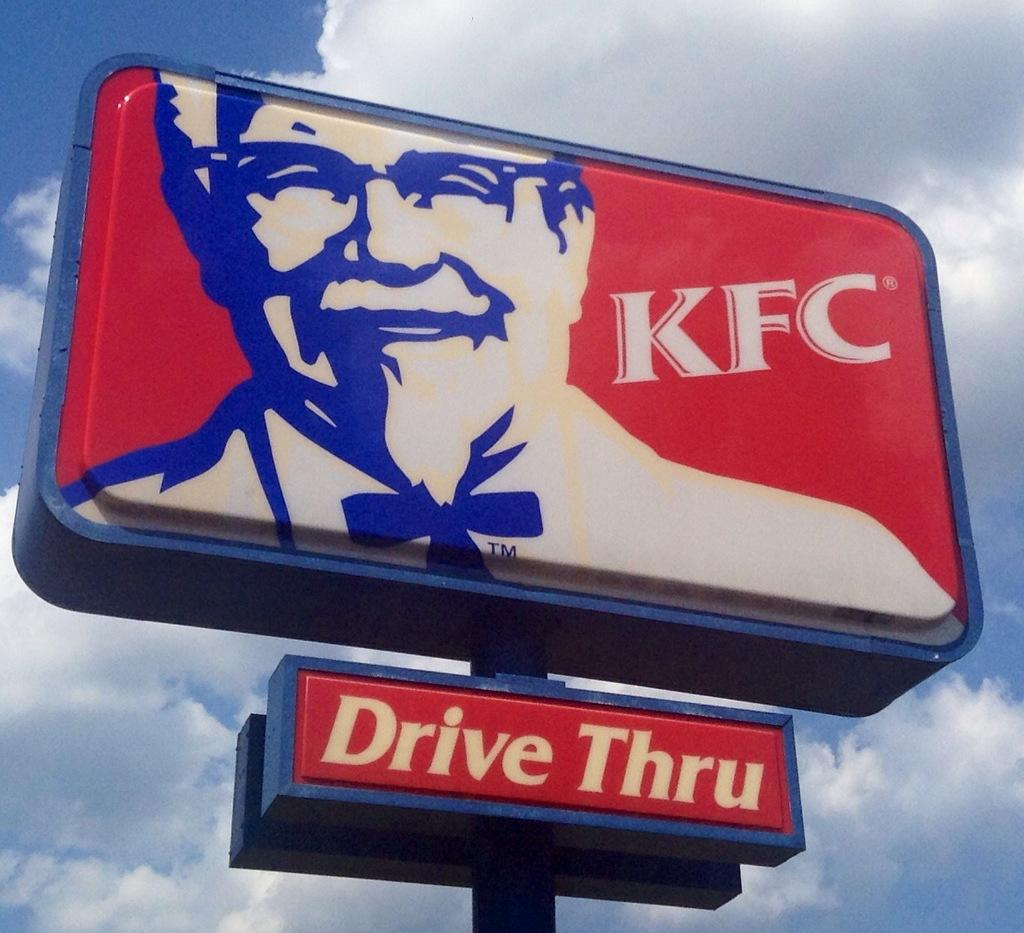<image>
Give a short and clear explanation of the subsequent image. Blue and red sign that says Drive Thru on it. 